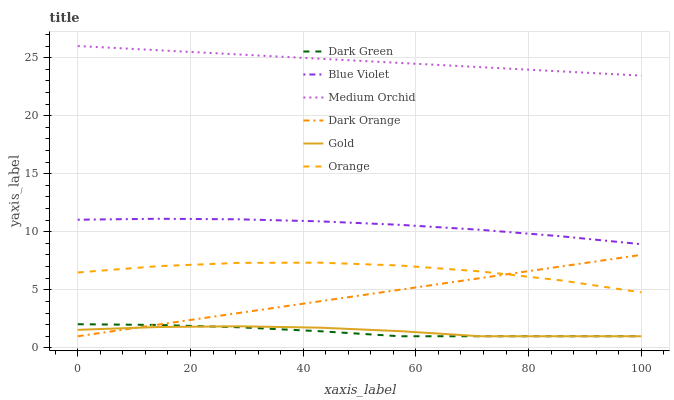Does Dark Green have the minimum area under the curve?
Answer yes or no. Yes. Does Medium Orchid have the maximum area under the curve?
Answer yes or no. Yes. Does Gold have the minimum area under the curve?
Answer yes or no. No. Does Gold have the maximum area under the curve?
Answer yes or no. No. Is Medium Orchid the smoothest?
Answer yes or no. Yes. Is Orange the roughest?
Answer yes or no. Yes. Is Gold the smoothest?
Answer yes or no. No. Is Gold the roughest?
Answer yes or no. No. Does Medium Orchid have the lowest value?
Answer yes or no. No. Does Medium Orchid have the highest value?
Answer yes or no. Yes. Does Gold have the highest value?
Answer yes or no. No. Is Dark Green less than Orange?
Answer yes or no. Yes. Is Medium Orchid greater than Dark Orange?
Answer yes or no. Yes. Does Dark Green intersect Orange?
Answer yes or no. No. 